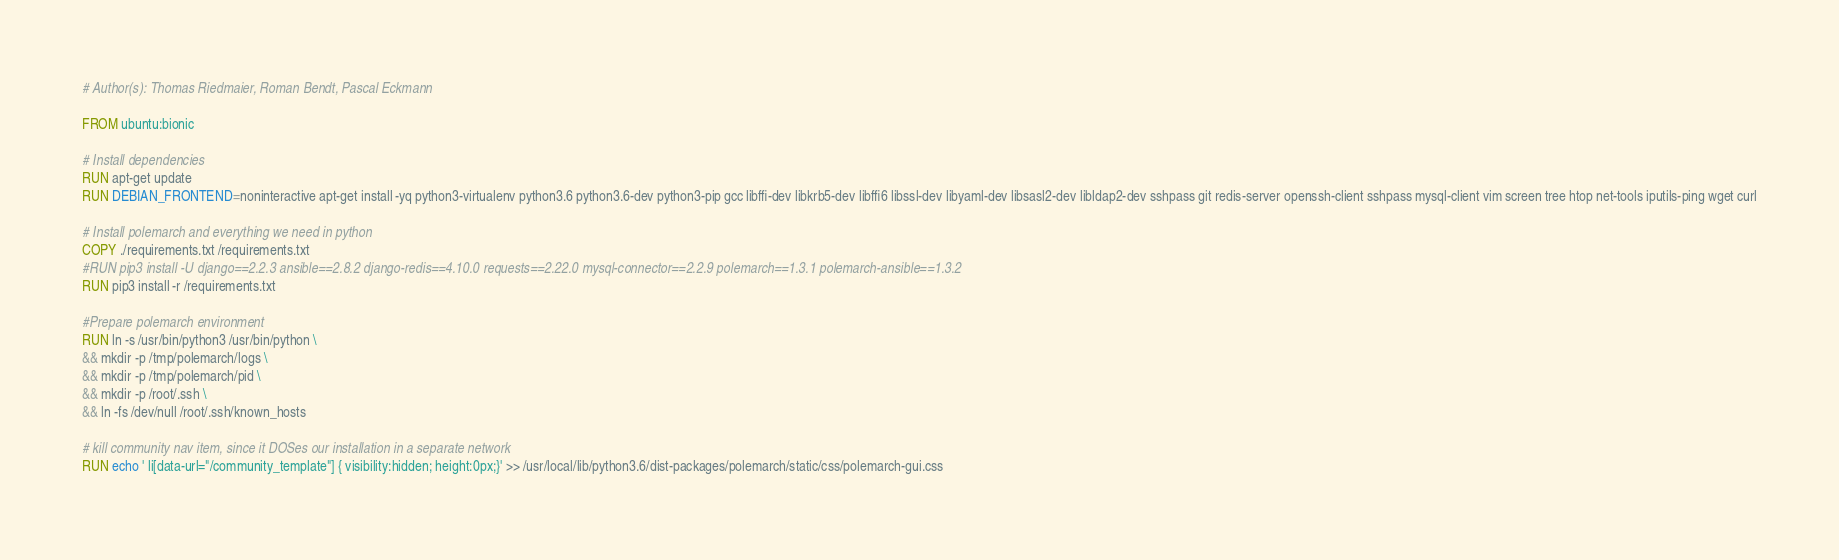<code> <loc_0><loc_0><loc_500><loc_500><_Dockerfile_># Author(s): Thomas Riedmaier, Roman Bendt, Pascal Eckmann

FROM ubuntu:bionic

# Install dependencies
RUN apt-get update
RUN DEBIAN_FRONTEND=noninteractive apt-get install -yq python3-virtualenv python3.6 python3.6-dev python3-pip gcc libffi-dev libkrb5-dev libffi6 libssl-dev libyaml-dev libsasl2-dev libldap2-dev sshpass git redis-server openssh-client sshpass mysql-client vim screen tree htop net-tools iputils-ping wget curl

# Install polemarch and everything we need in python
COPY ./requirements.txt /requirements.txt
#RUN pip3 install -U django==2.2.3 ansible==2.8.2 django-redis==4.10.0 requests==2.22.0 mysql-connector==2.2.9 polemarch==1.3.1 polemarch-ansible==1.3.2 
RUN pip3 install -r /requirements.txt

#Prepare polemarch environment
RUN ln -s /usr/bin/python3 /usr/bin/python \
&& mkdir -p /tmp/polemarch/logs \
&& mkdir -p /tmp/polemarch/pid \
&& mkdir -p /root/.ssh \
&& ln -fs /dev/null /root/.ssh/known_hosts

# kill community nav item, since it DOSes our installation in a separate network
RUN echo ' li[data-url="/community_template"] { visibility:hidden; height:0px;}' >> /usr/local/lib/python3.6/dist-packages/polemarch/static/css/polemarch-gui.css

</code> 